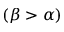Convert formula to latex. <formula><loc_0><loc_0><loc_500><loc_500>( \beta > \alpha )</formula> 